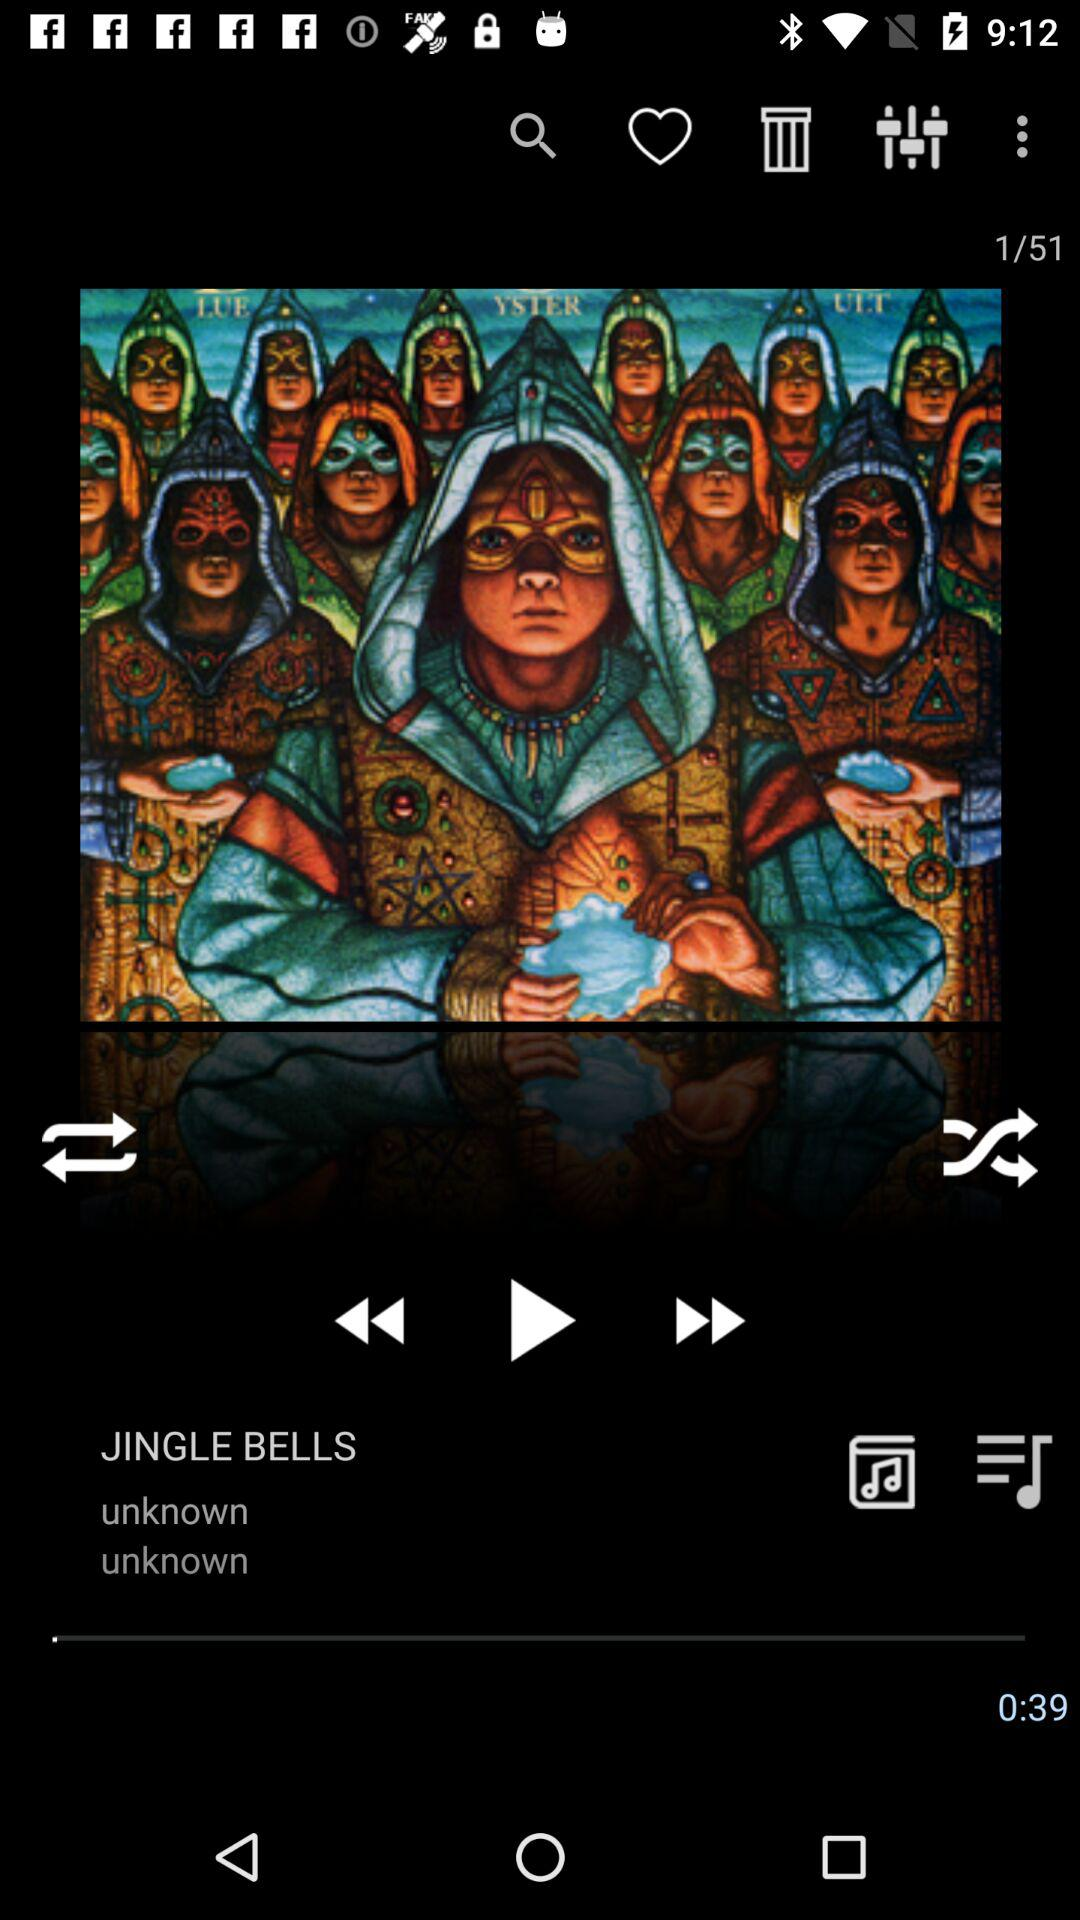Which track was last played? The last played song was "JINGLE BELLS". 